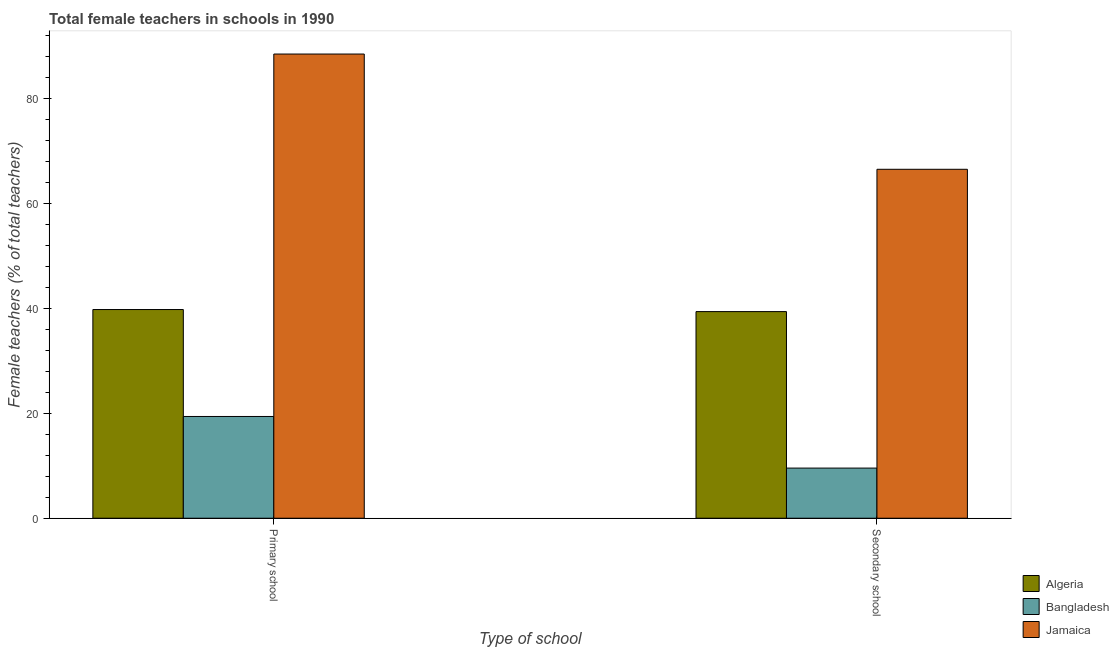How many different coloured bars are there?
Make the answer very short. 3. Are the number of bars per tick equal to the number of legend labels?
Provide a short and direct response. Yes. How many bars are there on the 1st tick from the right?
Make the answer very short. 3. What is the label of the 1st group of bars from the left?
Provide a succinct answer. Primary school. What is the percentage of female teachers in secondary schools in Algeria?
Provide a succinct answer. 39.36. Across all countries, what is the maximum percentage of female teachers in secondary schools?
Keep it short and to the point. 66.46. Across all countries, what is the minimum percentage of female teachers in secondary schools?
Offer a very short reply. 9.55. In which country was the percentage of female teachers in primary schools maximum?
Ensure brevity in your answer.  Jamaica. In which country was the percentage of female teachers in secondary schools minimum?
Your answer should be compact. Bangladesh. What is the total percentage of female teachers in primary schools in the graph?
Your answer should be very brief. 147.55. What is the difference between the percentage of female teachers in secondary schools in Bangladesh and that in Jamaica?
Provide a succinct answer. -56.91. What is the difference between the percentage of female teachers in primary schools in Jamaica and the percentage of female teachers in secondary schools in Bangladesh?
Provide a short and direct response. 78.87. What is the average percentage of female teachers in secondary schools per country?
Provide a succinct answer. 38.46. What is the difference between the percentage of female teachers in secondary schools and percentage of female teachers in primary schools in Jamaica?
Keep it short and to the point. -21.95. In how many countries, is the percentage of female teachers in secondary schools greater than 52 %?
Offer a terse response. 1. What is the ratio of the percentage of female teachers in primary schools in Jamaica to that in Bangladesh?
Provide a succinct answer. 4.56. What does the 1st bar from the left in Secondary school represents?
Make the answer very short. Algeria. What does the 3rd bar from the right in Primary school represents?
Keep it short and to the point. Algeria. How many bars are there?
Provide a succinct answer. 6. How many countries are there in the graph?
Your response must be concise. 3. What is the difference between two consecutive major ticks on the Y-axis?
Keep it short and to the point. 20. Are the values on the major ticks of Y-axis written in scientific E-notation?
Keep it short and to the point. No. Does the graph contain any zero values?
Give a very brief answer. No. How many legend labels are there?
Provide a succinct answer. 3. How are the legend labels stacked?
Offer a terse response. Vertical. What is the title of the graph?
Give a very brief answer. Total female teachers in schools in 1990. What is the label or title of the X-axis?
Your answer should be very brief. Type of school. What is the label or title of the Y-axis?
Keep it short and to the point. Female teachers (% of total teachers). What is the Female teachers (% of total teachers) in Algeria in Primary school?
Offer a very short reply. 39.75. What is the Female teachers (% of total teachers) in Bangladesh in Primary school?
Your response must be concise. 19.38. What is the Female teachers (% of total teachers) of Jamaica in Primary school?
Ensure brevity in your answer.  88.42. What is the Female teachers (% of total teachers) of Algeria in Secondary school?
Your response must be concise. 39.36. What is the Female teachers (% of total teachers) of Bangladesh in Secondary school?
Offer a terse response. 9.55. What is the Female teachers (% of total teachers) of Jamaica in Secondary school?
Provide a succinct answer. 66.46. Across all Type of school, what is the maximum Female teachers (% of total teachers) in Algeria?
Ensure brevity in your answer.  39.75. Across all Type of school, what is the maximum Female teachers (% of total teachers) of Bangladesh?
Provide a short and direct response. 19.38. Across all Type of school, what is the maximum Female teachers (% of total teachers) in Jamaica?
Provide a succinct answer. 88.42. Across all Type of school, what is the minimum Female teachers (% of total teachers) of Algeria?
Offer a terse response. 39.36. Across all Type of school, what is the minimum Female teachers (% of total teachers) of Bangladesh?
Provide a succinct answer. 9.55. Across all Type of school, what is the minimum Female teachers (% of total teachers) of Jamaica?
Provide a succinct answer. 66.46. What is the total Female teachers (% of total teachers) of Algeria in the graph?
Offer a very short reply. 79.11. What is the total Female teachers (% of total teachers) in Bangladesh in the graph?
Ensure brevity in your answer.  28.93. What is the total Female teachers (% of total teachers) of Jamaica in the graph?
Your answer should be compact. 154.88. What is the difference between the Female teachers (% of total teachers) of Algeria in Primary school and that in Secondary school?
Your answer should be compact. 0.39. What is the difference between the Female teachers (% of total teachers) of Bangladesh in Primary school and that in Secondary school?
Ensure brevity in your answer.  9.83. What is the difference between the Female teachers (% of total teachers) of Jamaica in Primary school and that in Secondary school?
Your answer should be compact. 21.95. What is the difference between the Female teachers (% of total teachers) in Algeria in Primary school and the Female teachers (% of total teachers) in Bangladesh in Secondary school?
Give a very brief answer. 30.2. What is the difference between the Female teachers (% of total teachers) of Algeria in Primary school and the Female teachers (% of total teachers) of Jamaica in Secondary school?
Make the answer very short. -26.71. What is the difference between the Female teachers (% of total teachers) of Bangladesh in Primary school and the Female teachers (% of total teachers) of Jamaica in Secondary school?
Provide a short and direct response. -47.08. What is the average Female teachers (% of total teachers) in Algeria per Type of school?
Your answer should be compact. 39.55. What is the average Female teachers (% of total teachers) of Bangladesh per Type of school?
Offer a terse response. 14.47. What is the average Female teachers (% of total teachers) in Jamaica per Type of school?
Keep it short and to the point. 77.44. What is the difference between the Female teachers (% of total teachers) of Algeria and Female teachers (% of total teachers) of Bangladesh in Primary school?
Give a very brief answer. 20.37. What is the difference between the Female teachers (% of total teachers) of Algeria and Female teachers (% of total teachers) of Jamaica in Primary school?
Provide a succinct answer. -48.67. What is the difference between the Female teachers (% of total teachers) in Bangladesh and Female teachers (% of total teachers) in Jamaica in Primary school?
Give a very brief answer. -69.04. What is the difference between the Female teachers (% of total teachers) of Algeria and Female teachers (% of total teachers) of Bangladesh in Secondary school?
Keep it short and to the point. 29.81. What is the difference between the Female teachers (% of total teachers) of Algeria and Female teachers (% of total teachers) of Jamaica in Secondary school?
Provide a short and direct response. -27.11. What is the difference between the Female teachers (% of total teachers) of Bangladesh and Female teachers (% of total teachers) of Jamaica in Secondary school?
Your response must be concise. -56.91. What is the ratio of the Female teachers (% of total teachers) of Algeria in Primary school to that in Secondary school?
Give a very brief answer. 1.01. What is the ratio of the Female teachers (% of total teachers) of Bangladesh in Primary school to that in Secondary school?
Give a very brief answer. 2.03. What is the ratio of the Female teachers (% of total teachers) in Jamaica in Primary school to that in Secondary school?
Offer a terse response. 1.33. What is the difference between the highest and the second highest Female teachers (% of total teachers) in Algeria?
Your response must be concise. 0.39. What is the difference between the highest and the second highest Female teachers (% of total teachers) in Bangladesh?
Give a very brief answer. 9.83. What is the difference between the highest and the second highest Female teachers (% of total teachers) in Jamaica?
Offer a terse response. 21.95. What is the difference between the highest and the lowest Female teachers (% of total teachers) in Algeria?
Provide a succinct answer. 0.39. What is the difference between the highest and the lowest Female teachers (% of total teachers) in Bangladesh?
Give a very brief answer. 9.83. What is the difference between the highest and the lowest Female teachers (% of total teachers) in Jamaica?
Offer a terse response. 21.95. 